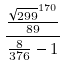<formula> <loc_0><loc_0><loc_500><loc_500>\frac { \frac { \sqrt { 2 9 9 } ^ { 1 7 0 } } { 8 9 } } { \frac { 8 } { 3 7 6 } - 1 }</formula> 